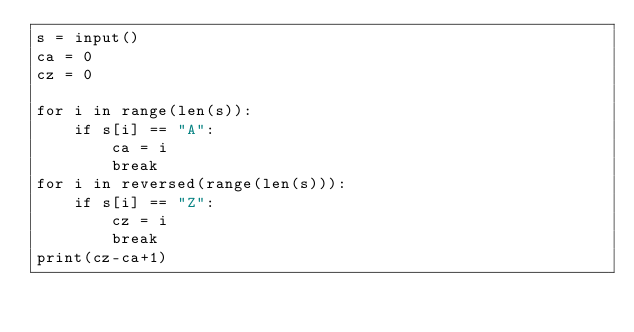Convert code to text. <code><loc_0><loc_0><loc_500><loc_500><_Python_>s = input()
ca = 0
cz = 0

for i in range(len(s)):
    if s[i] == "A":
        ca = i
        break
for i in reversed(range(len(s))):
    if s[i] == "Z":
        cz = i
        break
print(cz-ca+1)
</code> 